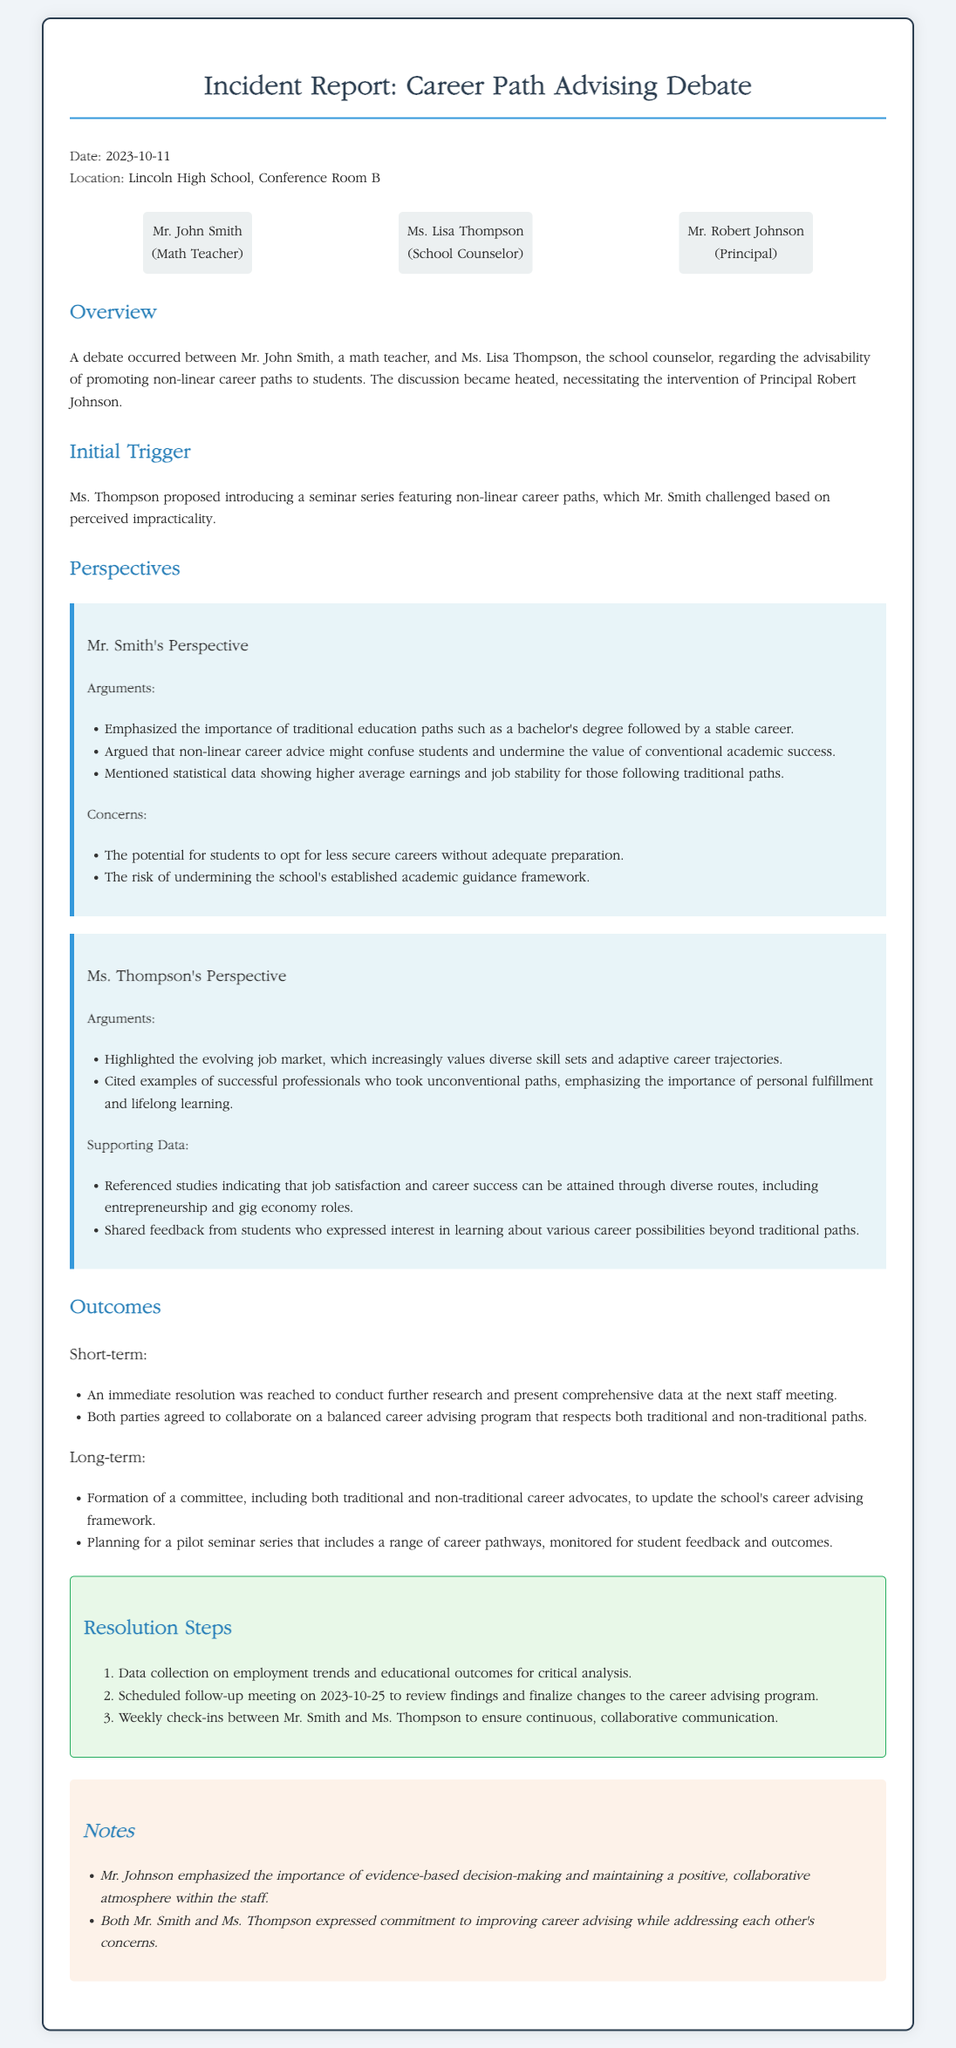What is the date of the incident report? The incident report states the date as 2023-10-11.
Answer: 2023-10-11 Who is the school counselor involved in the debate? The document identifies Ms. Lisa Thompson as the school counselor.
Answer: Ms. Lisa Thompson What triggered the debate between Mr. Smith and Ms. Thompson? The debate was triggered by Ms. Thompson proposing a seminar series featuring non-linear career paths.
Answer: Seminar series How many participants were involved in the incident? The document lists three participants involved in the debate.
Answer: Three What was one of Mr. Smith's concerns regarding non-linear career paths? Mr. Smith expressed concern about students opting for less secure careers without adequate preparation.
Answer: Less secure careers What immediate outcome was agreed upon during the incident? An immediate resolution was reached to conduct further research and present comprehensive data at the next staff meeting.
Answer: Conduct further research What long-term plan was formed as an outcome of the debate? The long-term plan included the formation of a committee to update the school's career advising framework.
Answer: Formation of a committee When is the scheduled follow-up meeting to review findings? The follow-up meeting is scheduled for 2023-10-25, as noted in the resolution steps.
Answer: 2023-10-25 What atmosphere did Mr. Johnson emphasize during the discussions? Mr. Johnson emphasized the importance of maintaining a positive, collaborative atmosphere within the staff.
Answer: Positive, collaborative atmosphere 